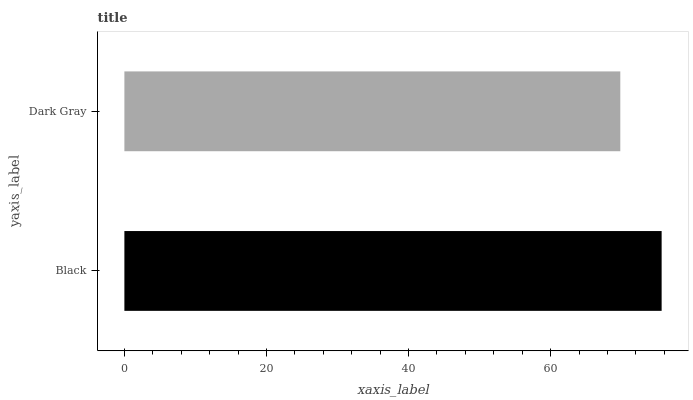Is Dark Gray the minimum?
Answer yes or no. Yes. Is Black the maximum?
Answer yes or no. Yes. Is Dark Gray the maximum?
Answer yes or no. No. Is Black greater than Dark Gray?
Answer yes or no. Yes. Is Dark Gray less than Black?
Answer yes or no. Yes. Is Dark Gray greater than Black?
Answer yes or no. No. Is Black less than Dark Gray?
Answer yes or no. No. Is Black the high median?
Answer yes or no. Yes. Is Dark Gray the low median?
Answer yes or no. Yes. Is Dark Gray the high median?
Answer yes or no. No. Is Black the low median?
Answer yes or no. No. 